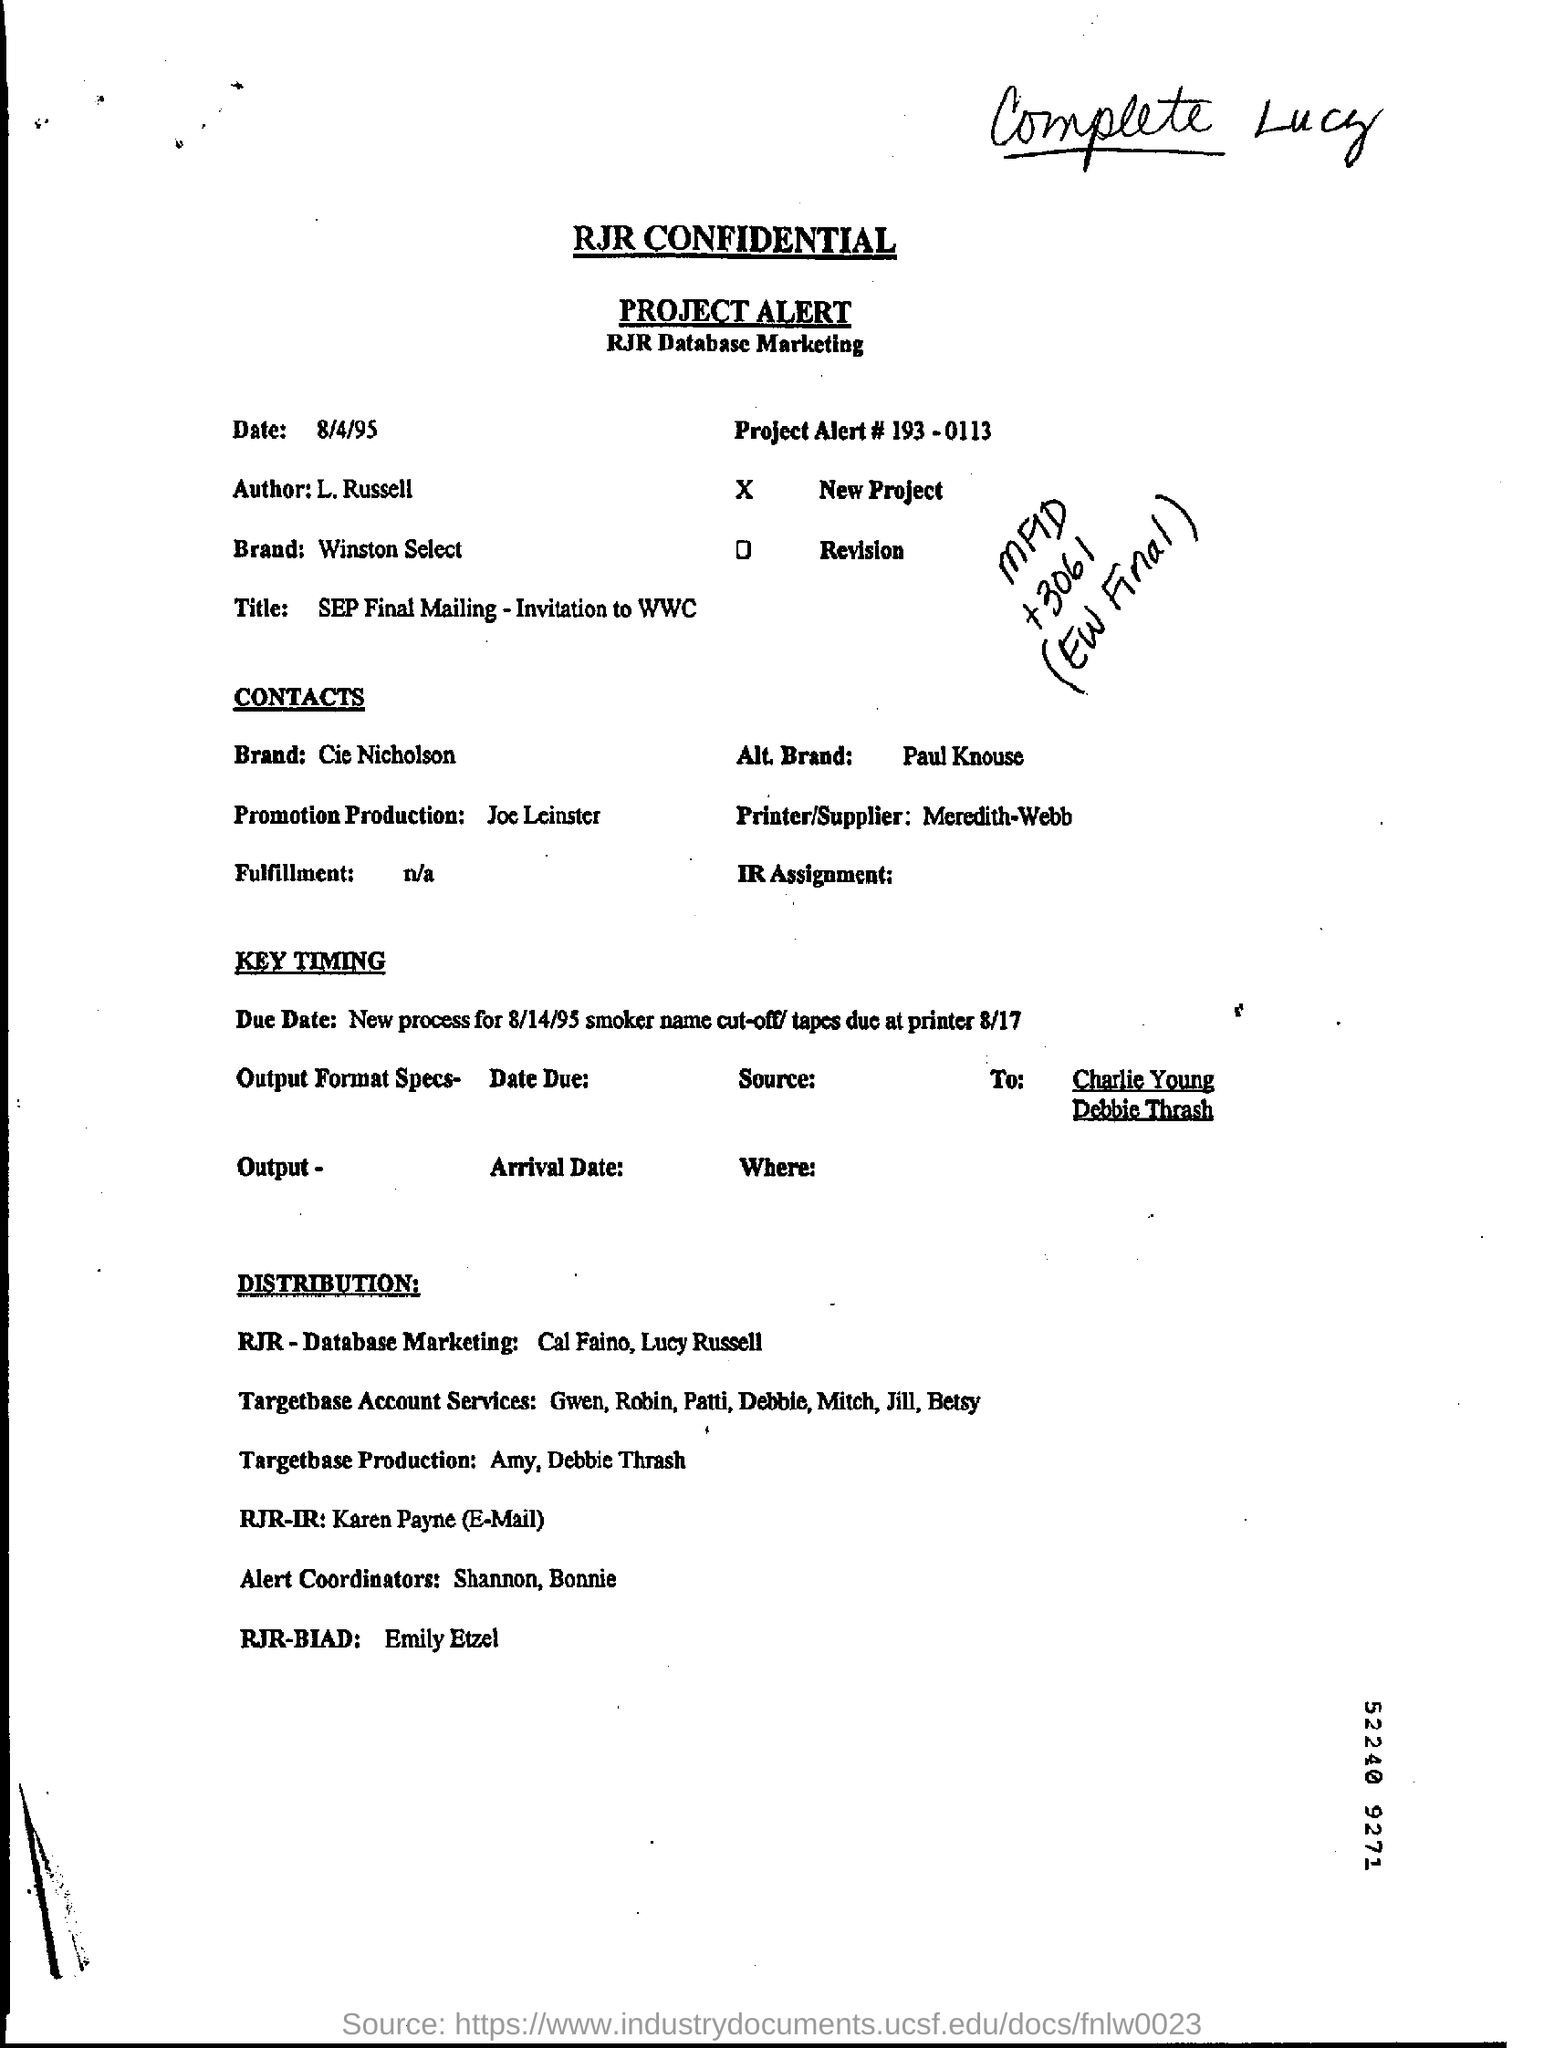Draw attention to some important aspects in this diagram. The Project Alert Number is 193-0113. The information written in the Promotion and Production Field is "Joe Leinster. It is mentioned in the alternative brand that Paul Knouse is involved. The date mentioned at the top of the document is August 4, 1995. The author name is L. Russell. 